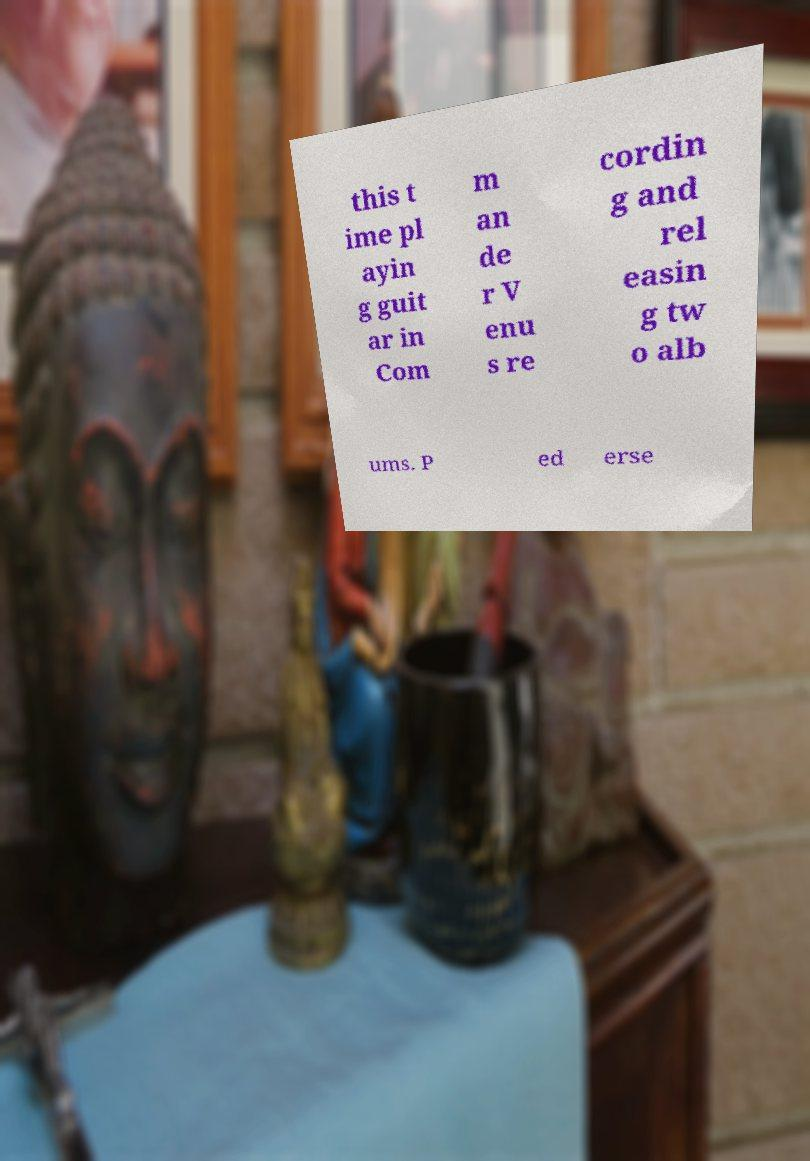There's text embedded in this image that I need extracted. Can you transcribe it verbatim? this t ime pl ayin g guit ar in Com m an de r V enu s re cordin g and rel easin g tw o alb ums. P ed erse 